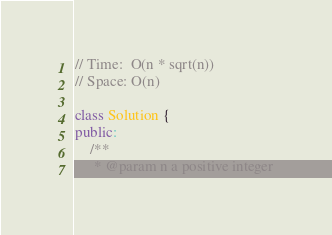<code> <loc_0><loc_0><loc_500><loc_500><_C++_>// Time:  O(n * sqrt(n))
// Space: O(n)

class Solution {
public:
    /**
     * @param n a positive integer</code> 